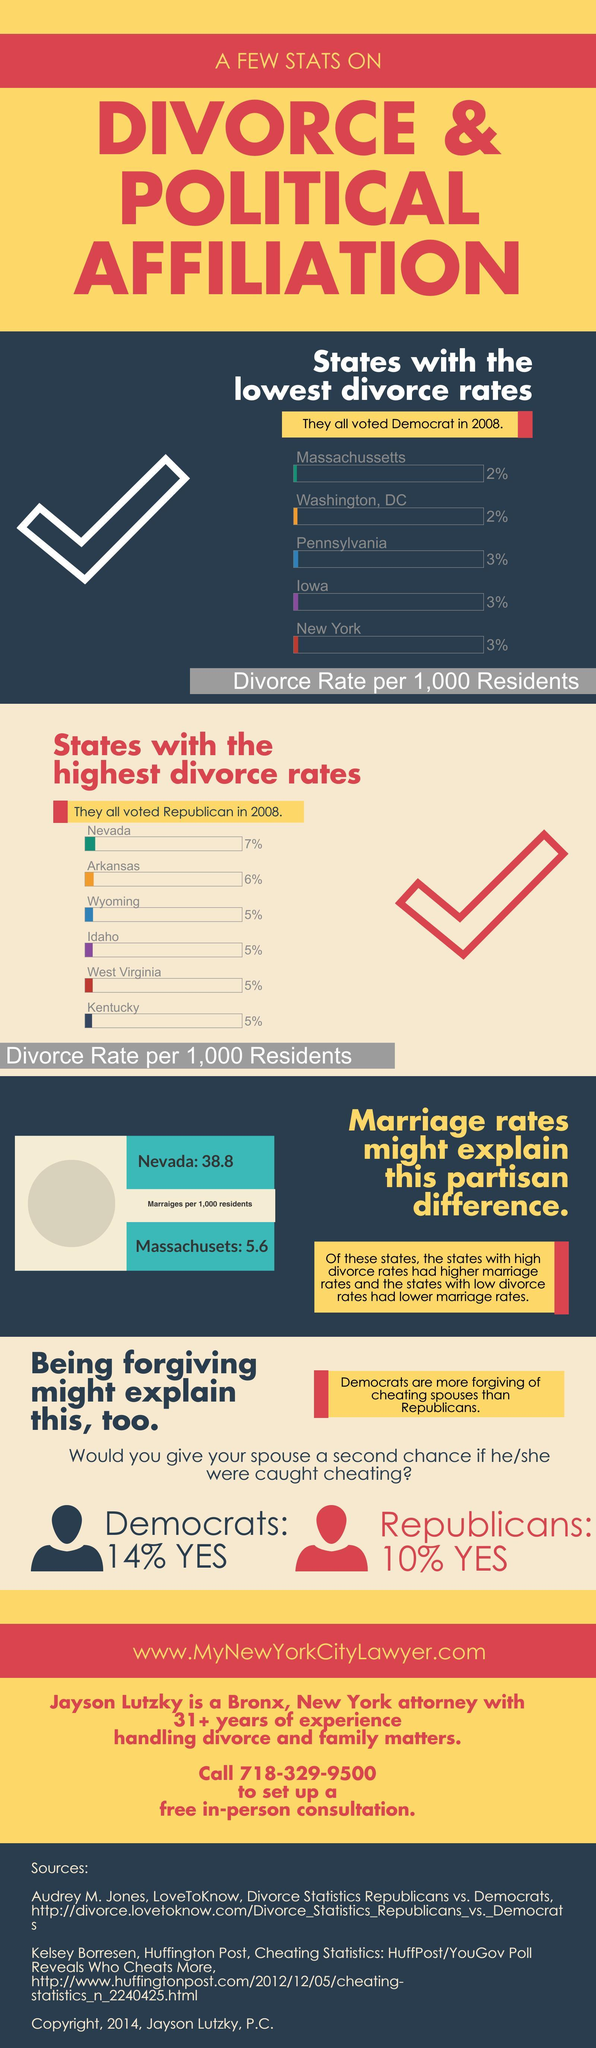How many states have a divorce rate equal to 3%?
Answer the question with a short phrase. 3 How many states have a divorce rate equal to 2%? 2 How many Republicans would give one more chance to their husband if found dishonesty? 10% Which state has the second-highest divorce rate? Arkansas 